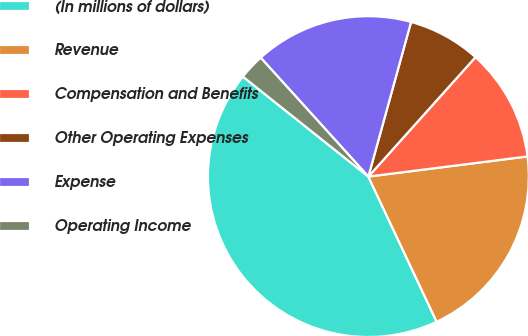Convert chart. <chart><loc_0><loc_0><loc_500><loc_500><pie_chart><fcel>(In millions of dollars)<fcel>Revenue<fcel>Compensation and Benefits<fcel>Other Operating Expenses<fcel>Expense<fcel>Operating Income<nl><fcel>42.71%<fcel>20.01%<fcel>11.36%<fcel>7.35%<fcel>16.0%<fcel>2.58%<nl></chart> 